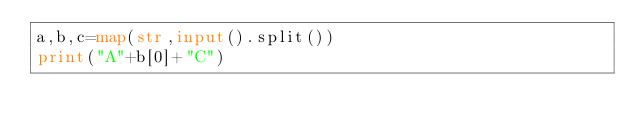Convert code to text. <code><loc_0><loc_0><loc_500><loc_500><_Python_>a,b,c=map(str,input().split())
print("A"+b[0]+"C")</code> 